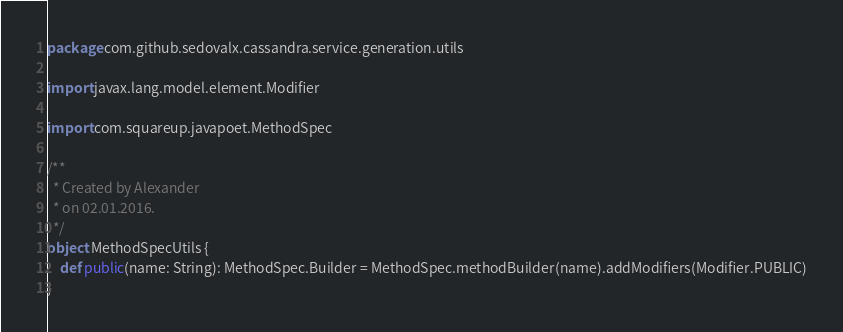<code> <loc_0><loc_0><loc_500><loc_500><_Scala_>package com.github.sedovalx.cassandra.service.generation.utils

import javax.lang.model.element.Modifier

import com.squareup.javapoet.MethodSpec

/**
  * Created by Alexander 
  * on 02.01.2016.
  */
object MethodSpecUtils {
    def public(name: String): MethodSpec.Builder = MethodSpec.methodBuilder(name).addModifiers(Modifier.PUBLIC)
}
</code> 